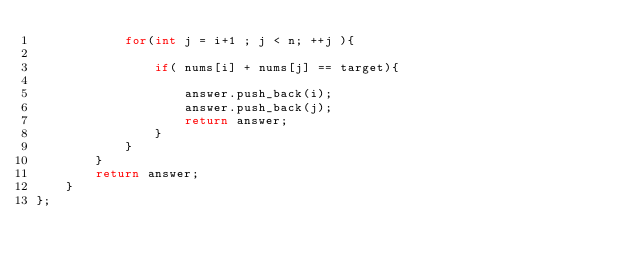Convert code to text. <code><loc_0><loc_0><loc_500><loc_500><_C++_>            for(int j = i+1 ; j < n; ++j ){
                
                if( nums[i] + nums[j] == target){
                    
                    answer.push_back(i);
                    answer.push_back(j);
                    return answer;    
                }
            }
        }
        return answer;
    }
};

</code> 